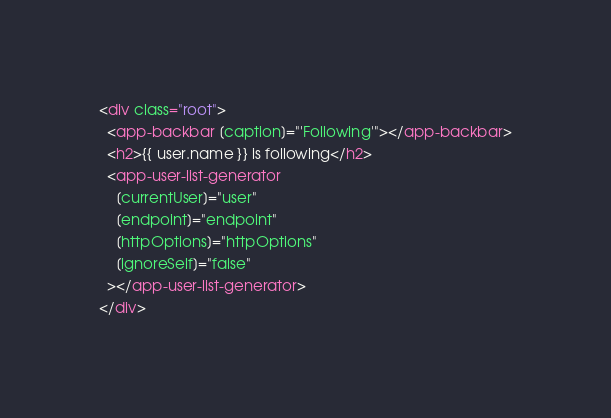<code> <loc_0><loc_0><loc_500><loc_500><_HTML_><div class="root">
  <app-backbar [caption]="'Following'"></app-backbar>
  <h2>{{ user.name }} is following</h2>
  <app-user-list-generator
    [currentUser]="user"
    [endpoint]="endpoint"
    [httpOptions]="httpOptions"
    [ignoreSelf]="false"
  ></app-user-list-generator>
</div>
</code> 